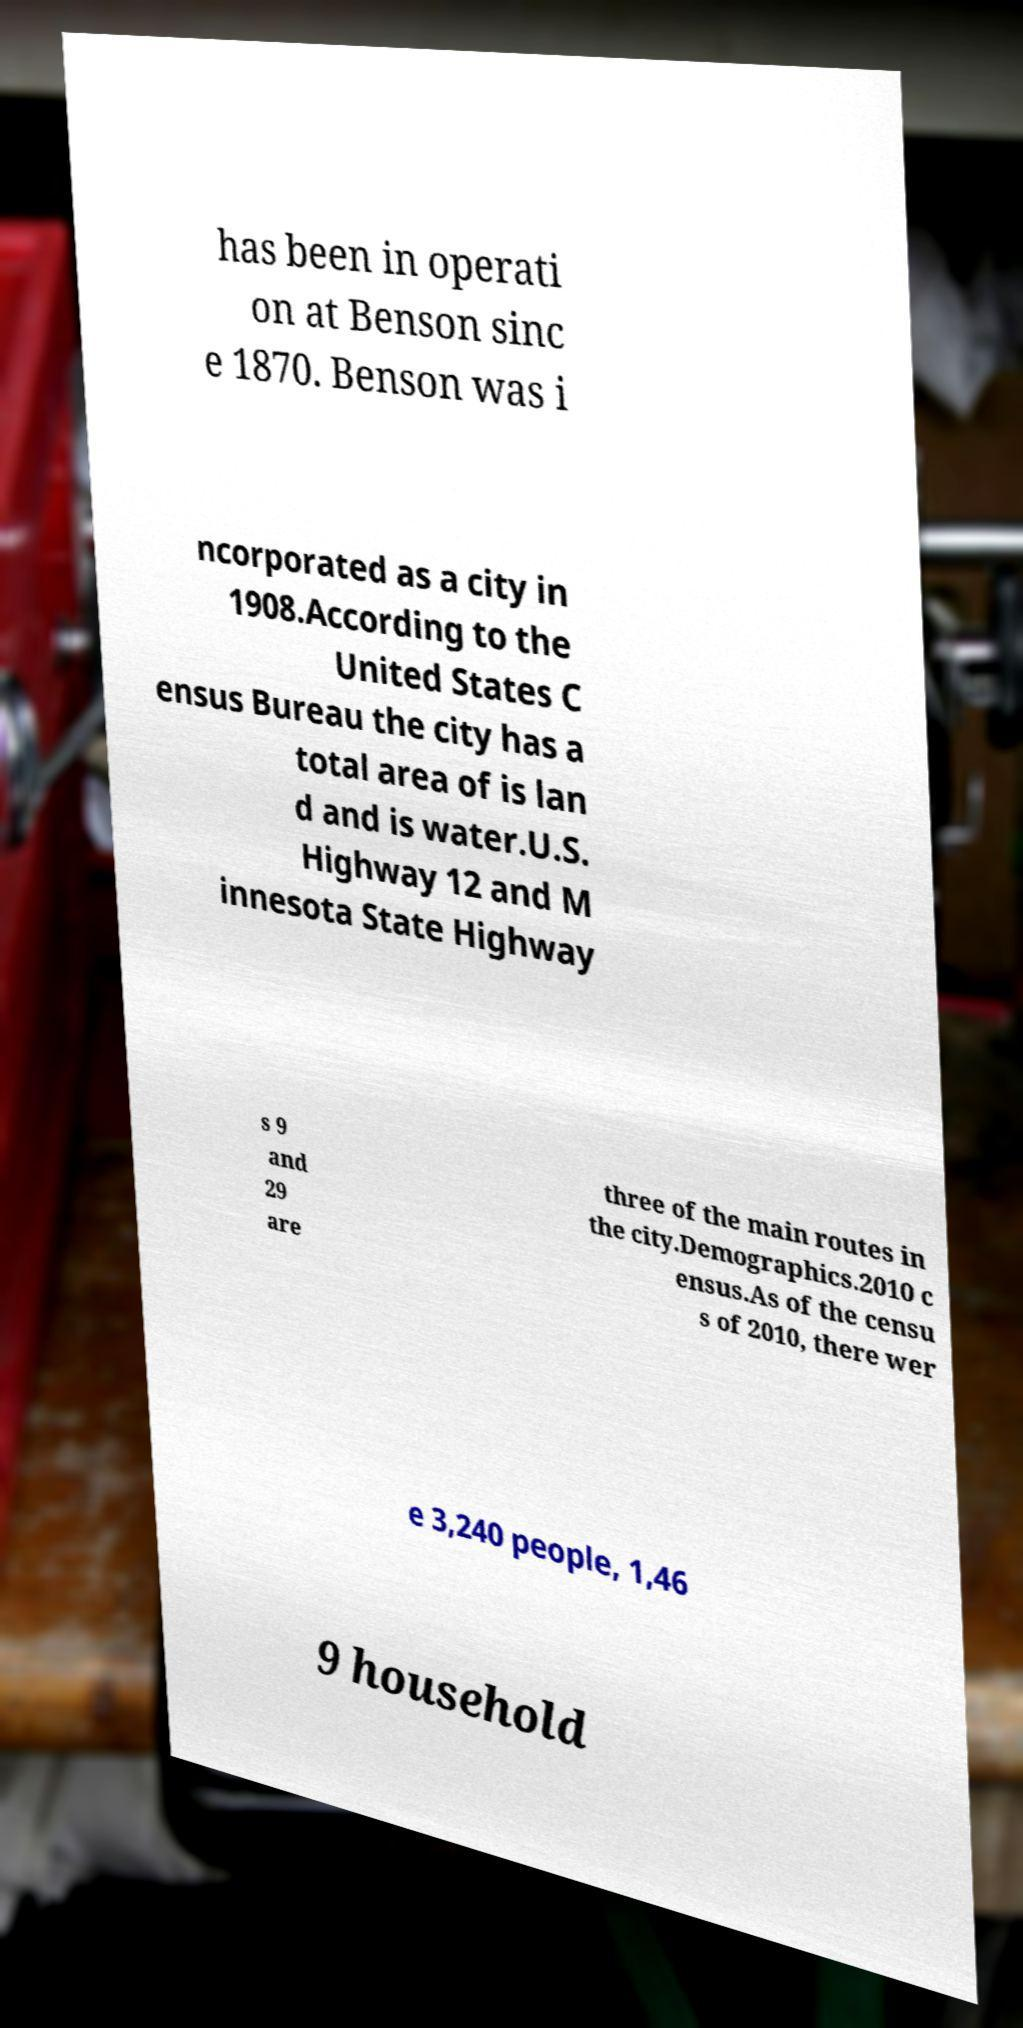Please identify and transcribe the text found in this image. has been in operati on at Benson sinc e 1870. Benson was i ncorporated as a city in 1908.According to the United States C ensus Bureau the city has a total area of is lan d and is water.U.S. Highway 12 and M innesota State Highway s 9 and 29 are three of the main routes in the city.Demographics.2010 c ensus.As of the censu s of 2010, there wer e 3,240 people, 1,46 9 household 